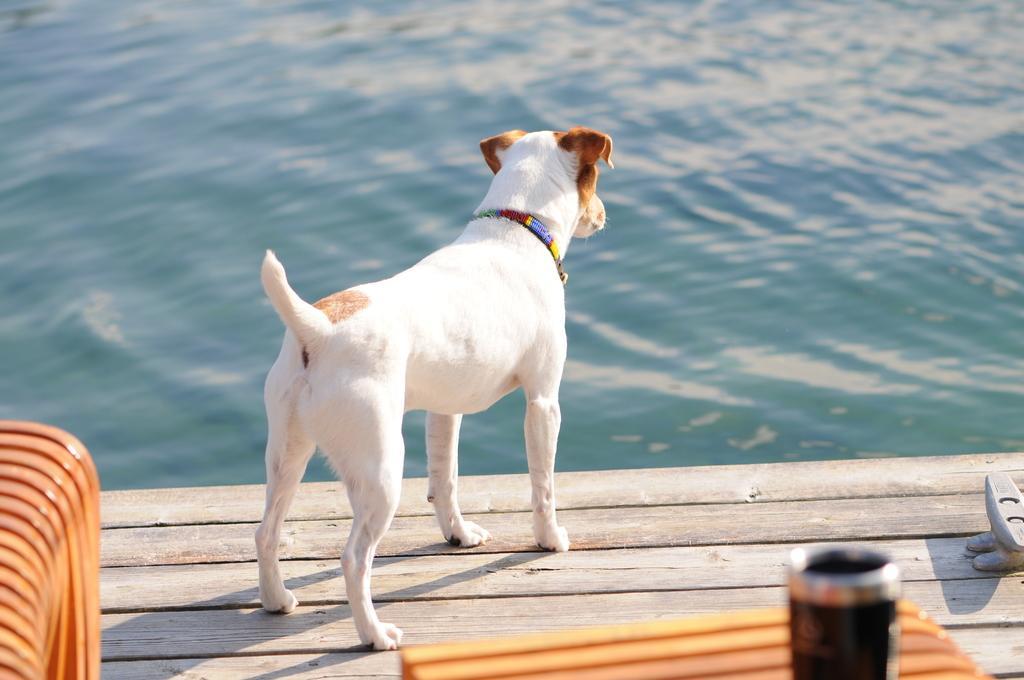Please provide a concise description of this image. In this picture, we see a white dog is on the wooden object. At the bottom, we see a stool on which a black color object is placed. On the left side, we see a wooden object. In the background, we see water and this water might be in the lake. 